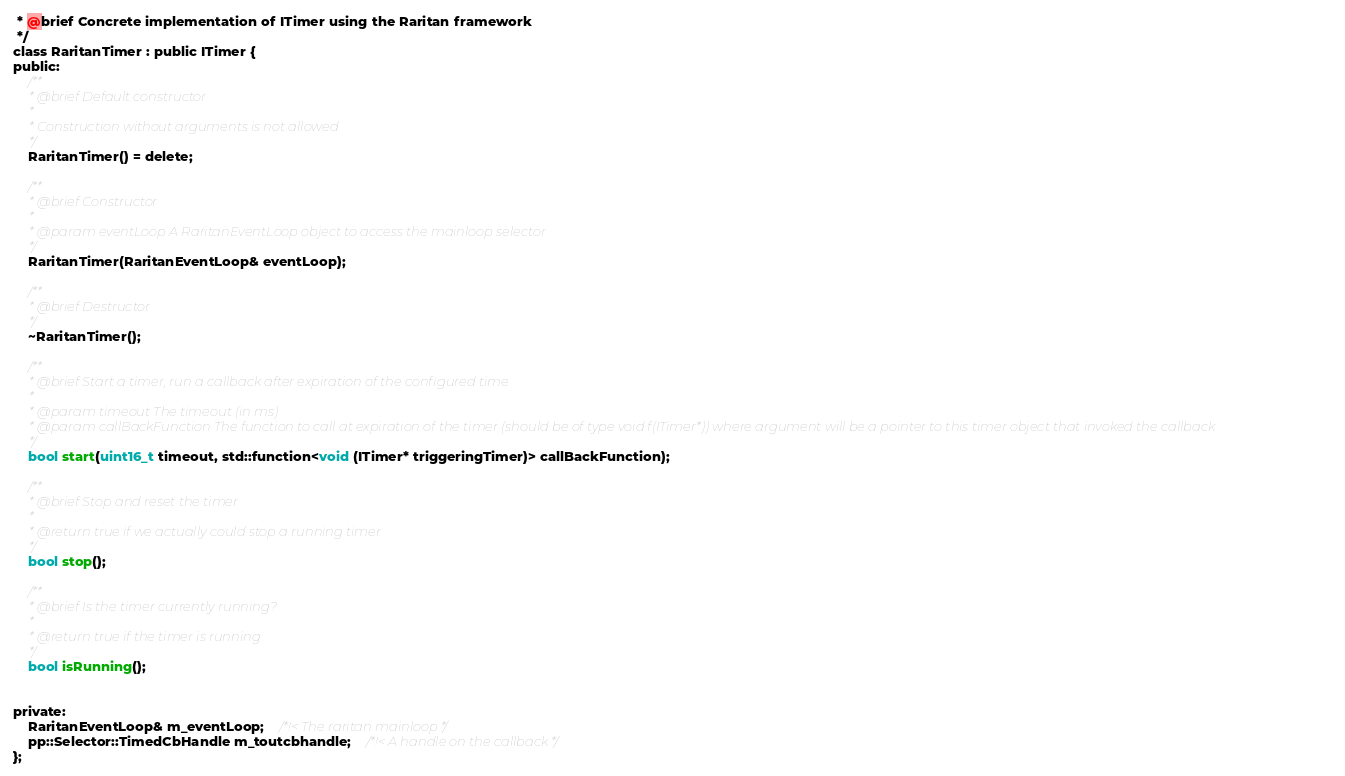Convert code to text. <code><loc_0><loc_0><loc_500><loc_500><_C_> * @brief Concrete implementation of ITimer using the Raritan framework
 */
class RaritanTimer : public ITimer {
public:
	/**
	 * @brief Default constructor
	 *
	 * Construction without arguments is not allowed
	 */
	RaritanTimer() = delete;

	/**
	 * @brief Constructor
	 *
	 * @param eventLoop A RaritanEventLoop object to access the mainloop selector
	 */
	RaritanTimer(RaritanEventLoop& eventLoop);

	/**
	 * @brief Destructor
	 */
	~RaritanTimer();

	/**
	 * @brief Start a timer, run a callback after expiration of the configured time
	 *
	 * @param timeout The timeout (in ms)
	 * @param callBackFunction The function to call at expiration of the timer (should be of type void f(ITimer*)) where argument will be a pointer to this timer object that invoked the callback
	 */
	bool start(uint16_t timeout, std::function<void (ITimer* triggeringTimer)> callBackFunction);

	/**
	 * @brief Stop and reset the timer
	 *
	 * @return true if we actually could stop a running timer
	 */
	bool stop();

	/**
	 * @brief Is the timer currently running?
	 *
	 * @return true if the timer is running
	 */
	bool isRunning();


private:
	RaritanEventLoop& m_eventLoop;	/*!< The raritan mainloop */
	pp::Selector::TimedCbHandle m_toutcbhandle;	/*!< A handle on the callback */
};
</code> 